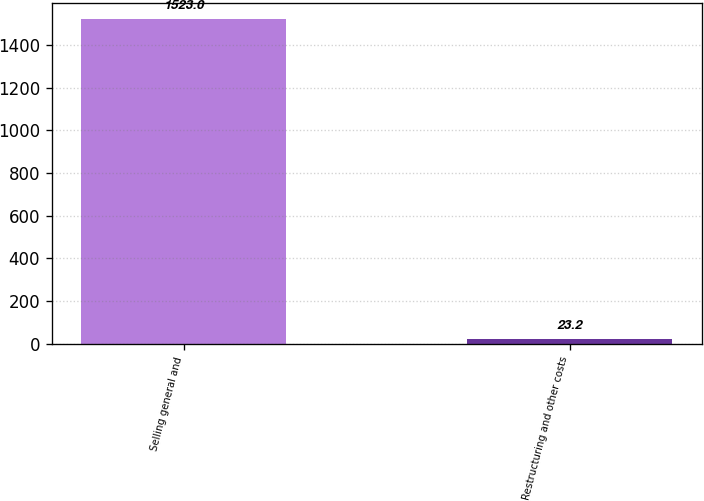Convert chart to OTSL. <chart><loc_0><loc_0><loc_500><loc_500><bar_chart><fcel>Selling general and<fcel>Restructuring and other costs<nl><fcel>1523<fcel>23.2<nl></chart> 